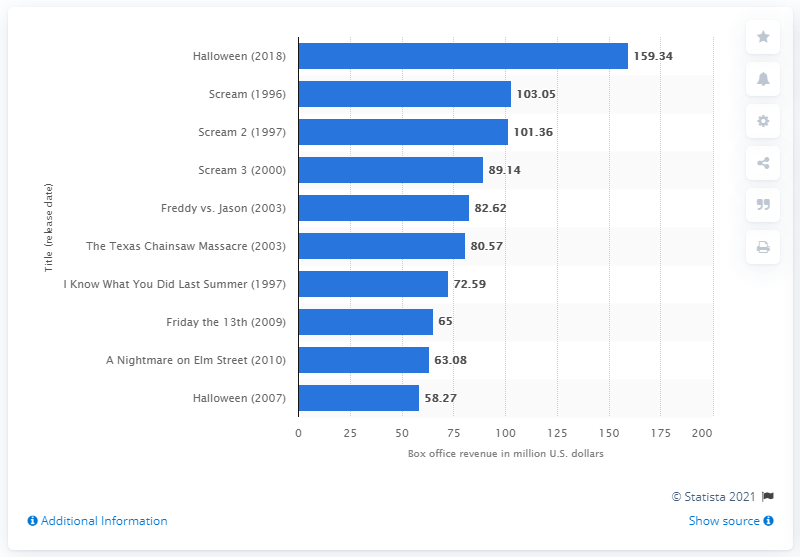Point out several critical features in this image. According to box office revenue, 'Halloween' generated $159.34 in total revenue. 